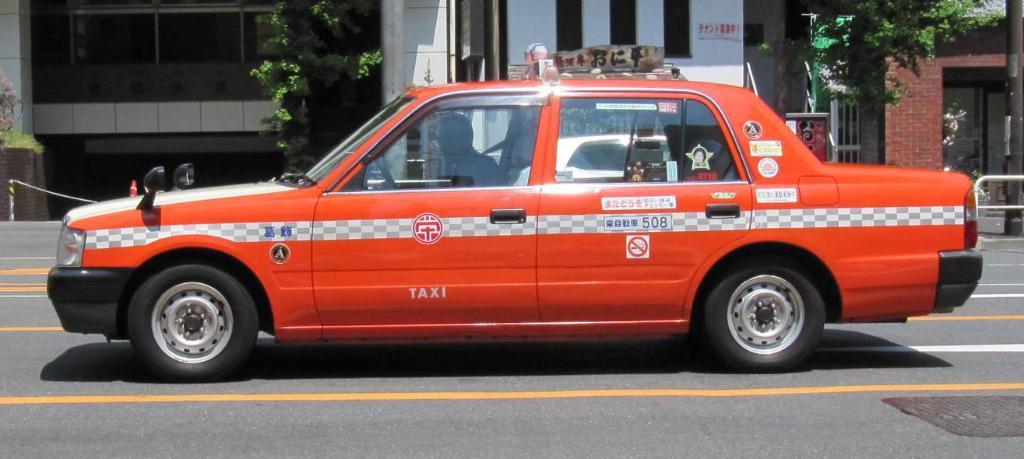In one or two sentences, can you explain what this image depicts? In this image I can see in the middle there is a car in orange color. At the back side there are buildings and trees. 